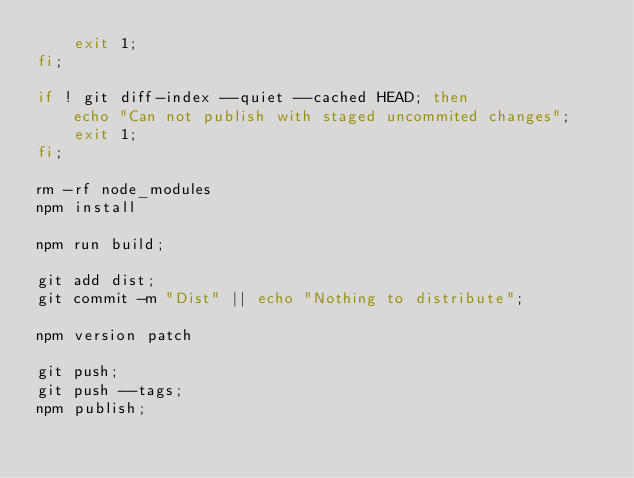<code> <loc_0><loc_0><loc_500><loc_500><_Bash_>    exit 1;
fi;

if ! git diff-index --quiet --cached HEAD; then
    echo "Can not publish with staged uncommited changes";
    exit 1;
fi;

rm -rf node_modules
npm install

npm run build;

git add dist;
git commit -m "Dist" || echo "Nothing to distribute";

npm version patch

git push;
git push --tags;
npm publish;
</code> 